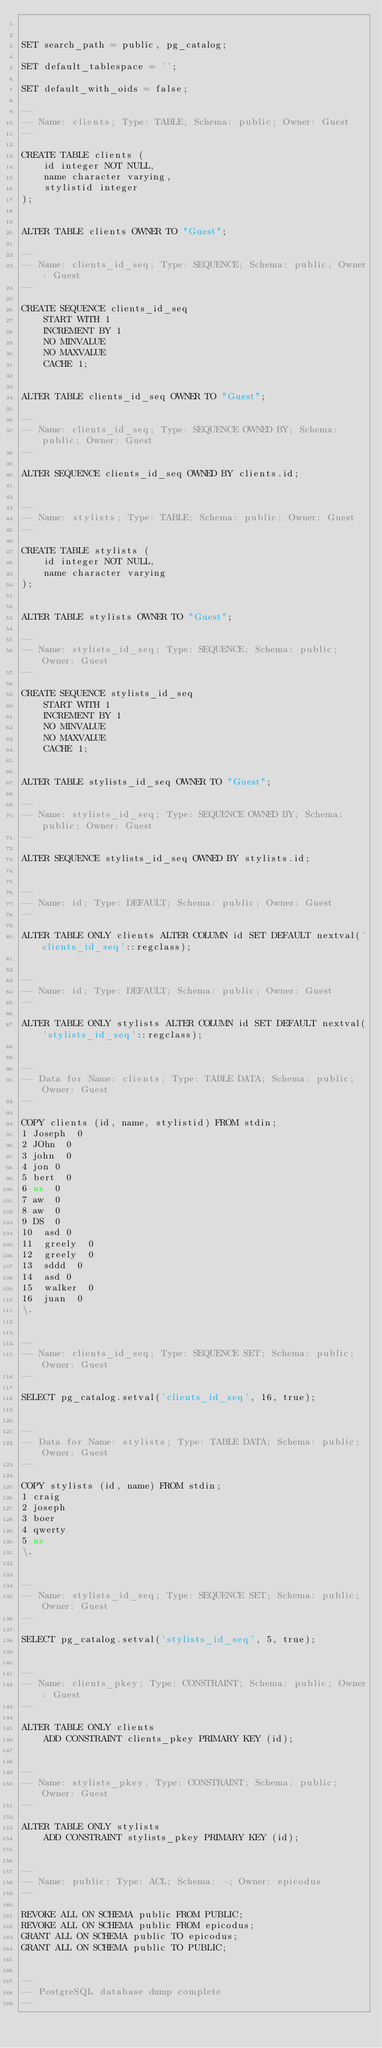Convert code to text. <code><loc_0><loc_0><loc_500><loc_500><_SQL_>

SET search_path = public, pg_catalog;

SET default_tablespace = '';

SET default_with_oids = false;

--
-- Name: clients; Type: TABLE; Schema: public; Owner: Guest
--

CREATE TABLE clients (
    id integer NOT NULL,
    name character varying,
    stylistid integer
);


ALTER TABLE clients OWNER TO "Guest";

--
-- Name: clients_id_seq; Type: SEQUENCE; Schema: public; Owner: Guest
--

CREATE SEQUENCE clients_id_seq
    START WITH 1
    INCREMENT BY 1
    NO MINVALUE
    NO MAXVALUE
    CACHE 1;


ALTER TABLE clients_id_seq OWNER TO "Guest";

--
-- Name: clients_id_seq; Type: SEQUENCE OWNED BY; Schema: public; Owner: Guest
--

ALTER SEQUENCE clients_id_seq OWNED BY clients.id;


--
-- Name: stylists; Type: TABLE; Schema: public; Owner: Guest
--

CREATE TABLE stylists (
    id integer NOT NULL,
    name character varying
);


ALTER TABLE stylists OWNER TO "Guest";

--
-- Name: stylists_id_seq; Type: SEQUENCE; Schema: public; Owner: Guest
--

CREATE SEQUENCE stylists_id_seq
    START WITH 1
    INCREMENT BY 1
    NO MINVALUE
    NO MAXVALUE
    CACHE 1;


ALTER TABLE stylists_id_seq OWNER TO "Guest";

--
-- Name: stylists_id_seq; Type: SEQUENCE OWNED BY; Schema: public; Owner: Guest
--

ALTER SEQUENCE stylists_id_seq OWNED BY stylists.id;


--
-- Name: id; Type: DEFAULT; Schema: public; Owner: Guest
--

ALTER TABLE ONLY clients ALTER COLUMN id SET DEFAULT nextval('clients_id_seq'::regclass);


--
-- Name: id; Type: DEFAULT; Schema: public; Owner: Guest
--

ALTER TABLE ONLY stylists ALTER COLUMN id SET DEFAULT nextval('stylists_id_seq'::regclass);


--
-- Data for Name: clients; Type: TABLE DATA; Schema: public; Owner: Guest
--

COPY clients (id, name, stylistid) FROM stdin;
1	Joseph	0
2	JOhn	0
3	john	0
4	jon	0
5	bert	0
6	as	0
7	aw	0
8	aw	0
9	DS	0
10	asd	0
11	greely	0
12	greely	0
13	sddd	0
14	asd	0
15	walker	0
16	juan	0
\.


--
-- Name: clients_id_seq; Type: SEQUENCE SET; Schema: public; Owner: Guest
--

SELECT pg_catalog.setval('clients_id_seq', 16, true);


--
-- Data for Name: stylists; Type: TABLE DATA; Schema: public; Owner: Guest
--

COPY stylists (id, name) FROM stdin;
1	craig
2	joseph
3	boer
4	qwerty
5	as
\.


--
-- Name: stylists_id_seq; Type: SEQUENCE SET; Schema: public; Owner: Guest
--

SELECT pg_catalog.setval('stylists_id_seq', 5, true);


--
-- Name: clients_pkey; Type: CONSTRAINT; Schema: public; Owner: Guest
--

ALTER TABLE ONLY clients
    ADD CONSTRAINT clients_pkey PRIMARY KEY (id);


--
-- Name: stylists_pkey; Type: CONSTRAINT; Schema: public; Owner: Guest
--

ALTER TABLE ONLY stylists
    ADD CONSTRAINT stylists_pkey PRIMARY KEY (id);


--
-- Name: public; Type: ACL; Schema: -; Owner: epicodus
--

REVOKE ALL ON SCHEMA public FROM PUBLIC;
REVOKE ALL ON SCHEMA public FROM epicodus;
GRANT ALL ON SCHEMA public TO epicodus;
GRANT ALL ON SCHEMA public TO PUBLIC;


--
-- PostgreSQL database dump complete
--

</code> 